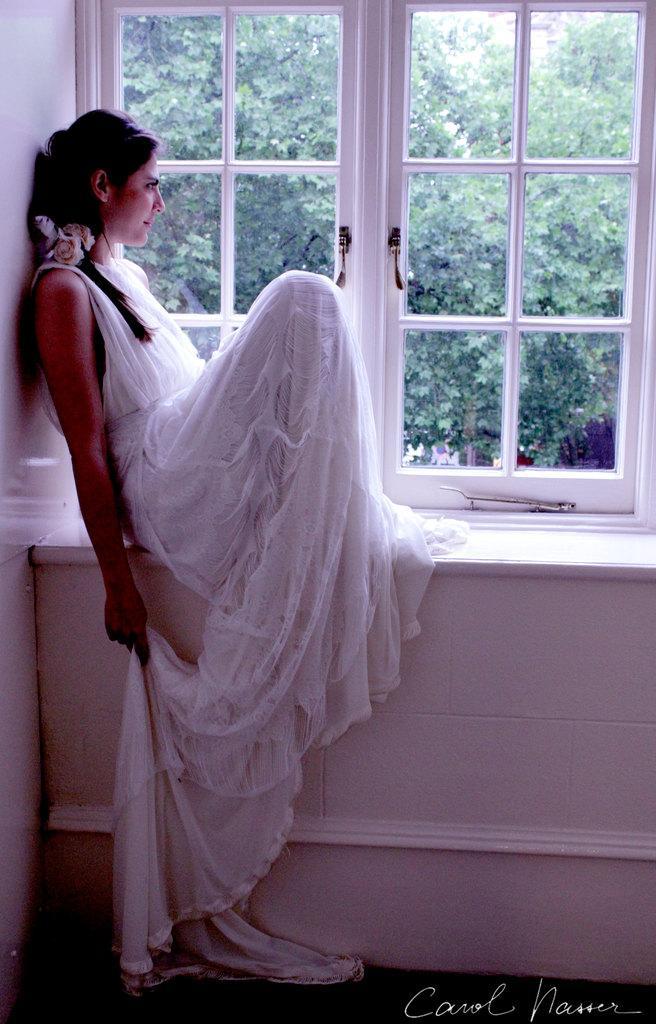Can you describe this image briefly? Here in this picture we can see a woman sitting over a place and she is wearing a white colored dress and smiling and beside her we can see a window, through which we can see plants and trees present outside. 